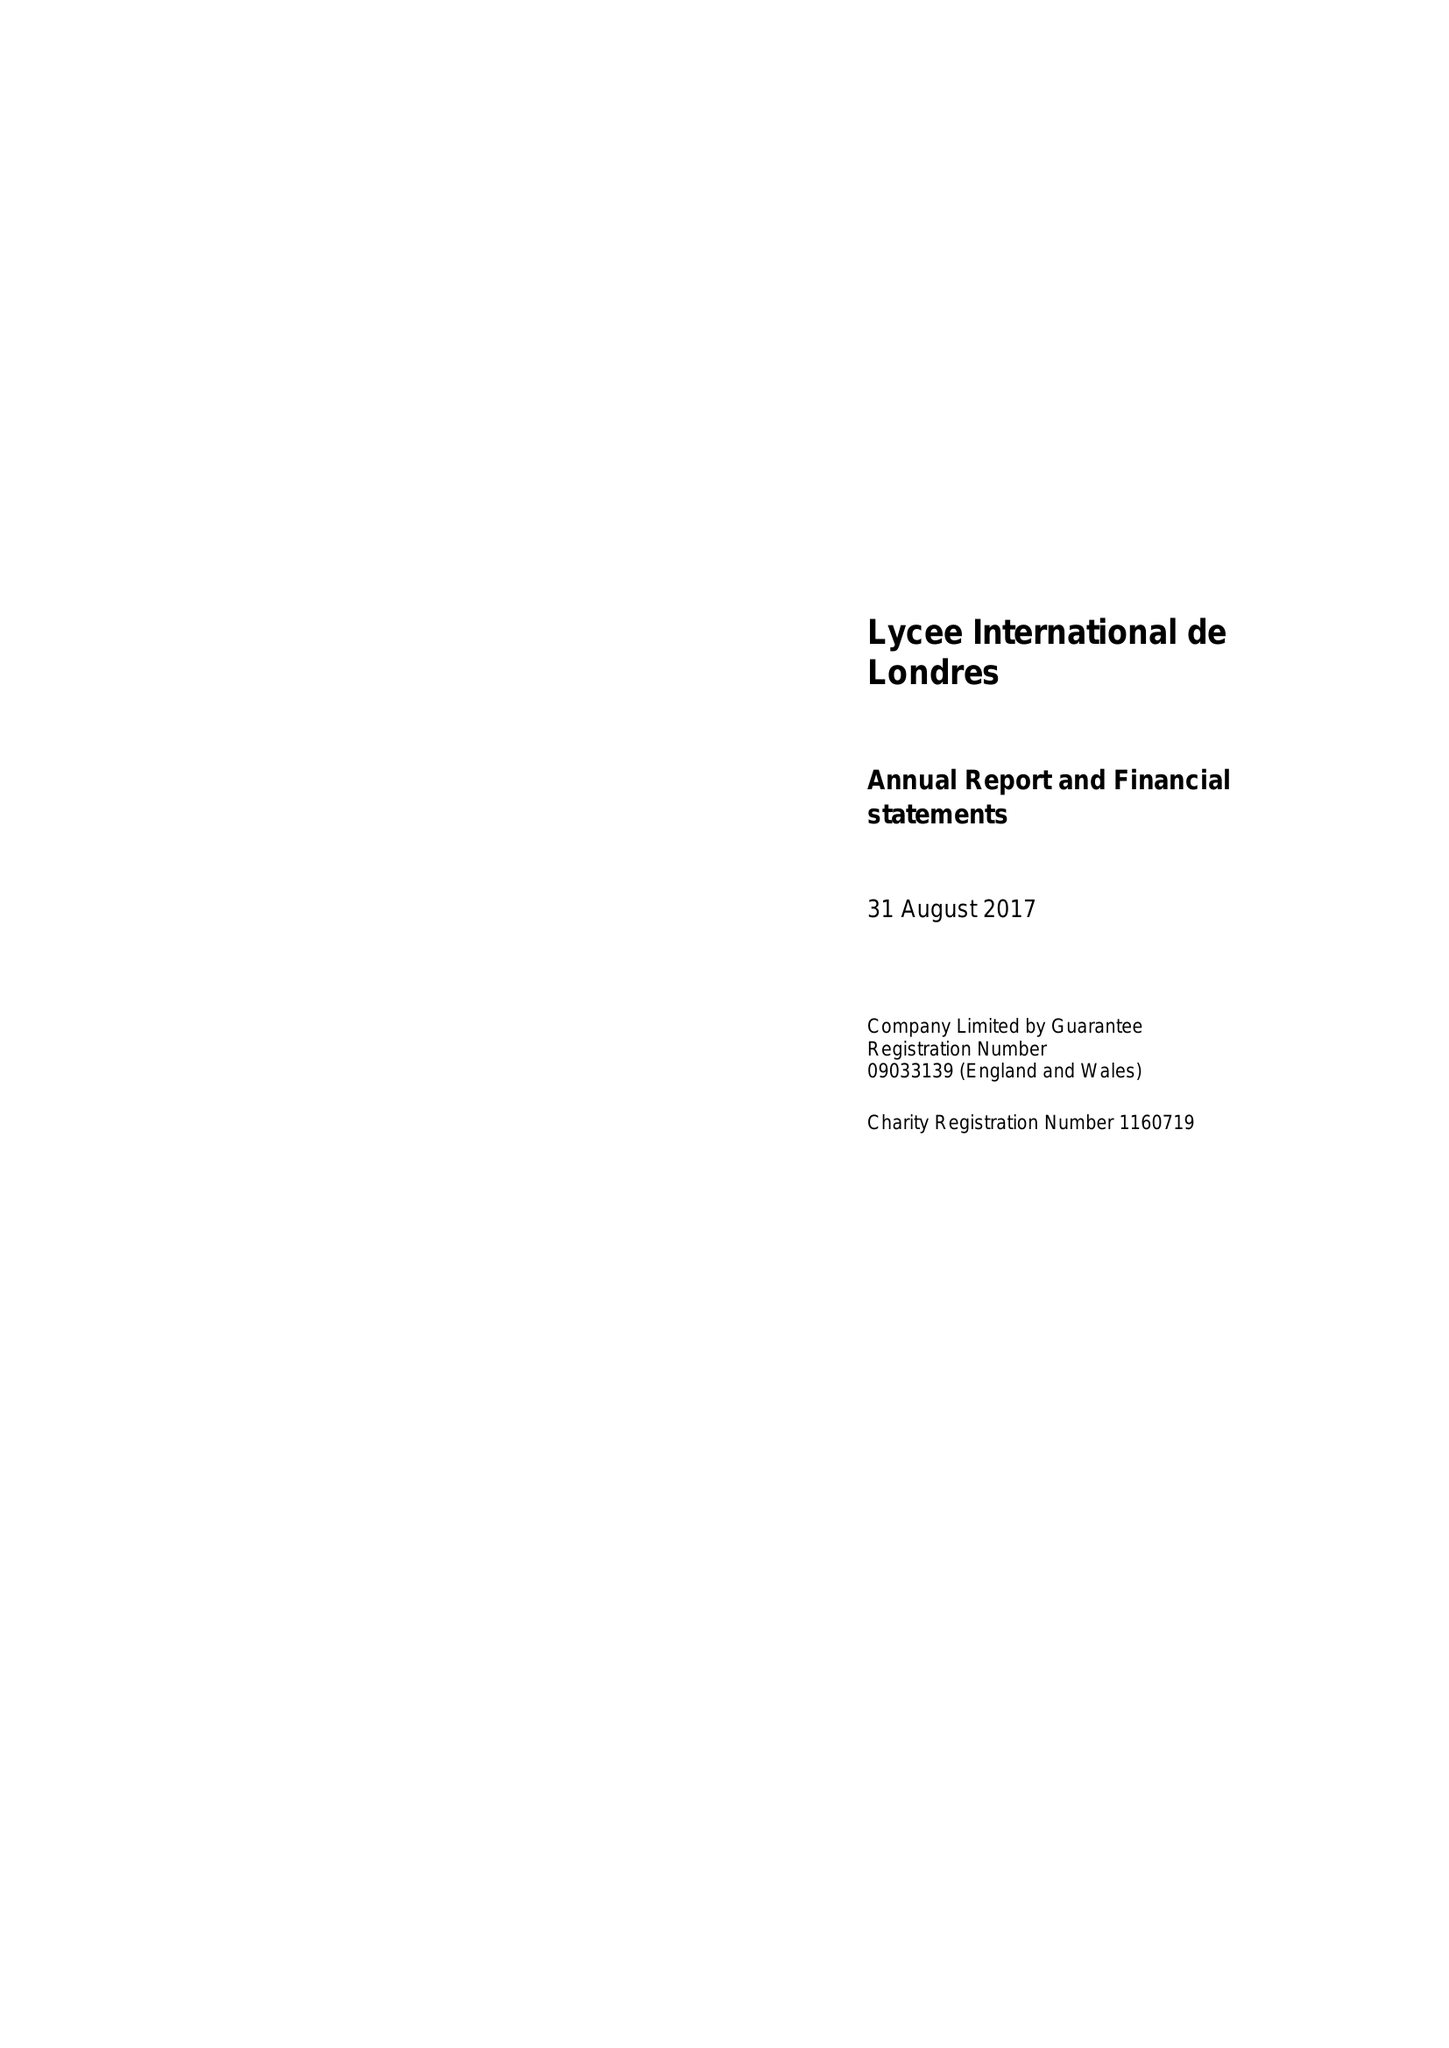What is the value for the charity_name?
Answer the question using a single word or phrase. Lycee International De Londres 